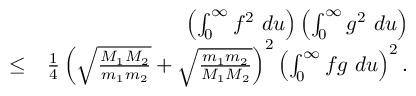<formula> <loc_0><loc_0><loc_500><loc_500>\begin{array} { r l r } & { \left ( \int _ { 0 } ^ { \infty } f ^ { 2 } d u \right ) \left ( \int _ { 0 } ^ { \infty } g ^ { 2 } d u \right ) } \\ & { \leq } & { \frac { 1 } { 4 } \left ( \sqrt { \frac { M _ { 1 } M _ { 2 } } { m _ { 1 } m _ { 2 } } } + \sqrt { \frac { m _ { 1 } m _ { 2 } } { M _ { 1 } M _ { 2 } } } \right ) ^ { 2 } \left ( \int _ { 0 } ^ { \infty } f g d u \right ) ^ { 2 } . } \\ & \end{array}</formula> 